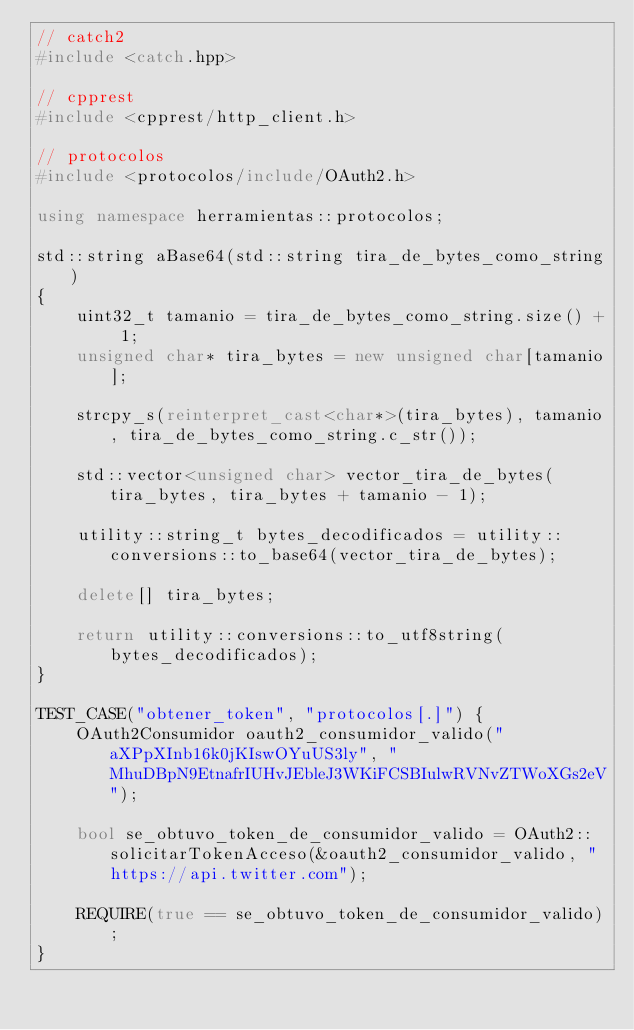<code> <loc_0><loc_0><loc_500><loc_500><_C++_>// catch2
#include <catch.hpp>

// cpprest
#include <cpprest/http_client.h>

// protocolos
#include <protocolos/include/OAuth2.h>

using namespace herramientas::protocolos;

std::string aBase64(std::string tira_de_bytes_como_string)
{
    uint32_t tamanio = tira_de_bytes_como_string.size() + 1;
    unsigned char* tira_bytes = new unsigned char[tamanio];

    strcpy_s(reinterpret_cast<char*>(tira_bytes), tamanio, tira_de_bytes_como_string.c_str());

    std::vector<unsigned char> vector_tira_de_bytes(tira_bytes, tira_bytes + tamanio - 1);

    utility::string_t bytes_decodificados = utility::conversions::to_base64(vector_tira_de_bytes);

    delete[] tira_bytes;

    return utility::conversions::to_utf8string(bytes_decodificados);
}

TEST_CASE("obtener_token", "protocolos[.]") {
    OAuth2Consumidor oauth2_consumidor_valido("aXPpXInb16k0jKIswOYuUS3ly", "MhuDBpN9EtnafrIUHvJEbleJ3WKiFCSBIulwRVNvZTWoXGs2eV");

    bool se_obtuvo_token_de_consumidor_valido = OAuth2::solicitarTokenAcceso(&oauth2_consumidor_valido, "https://api.twitter.com");

    REQUIRE(true == se_obtuvo_token_de_consumidor_valido);
}</code> 